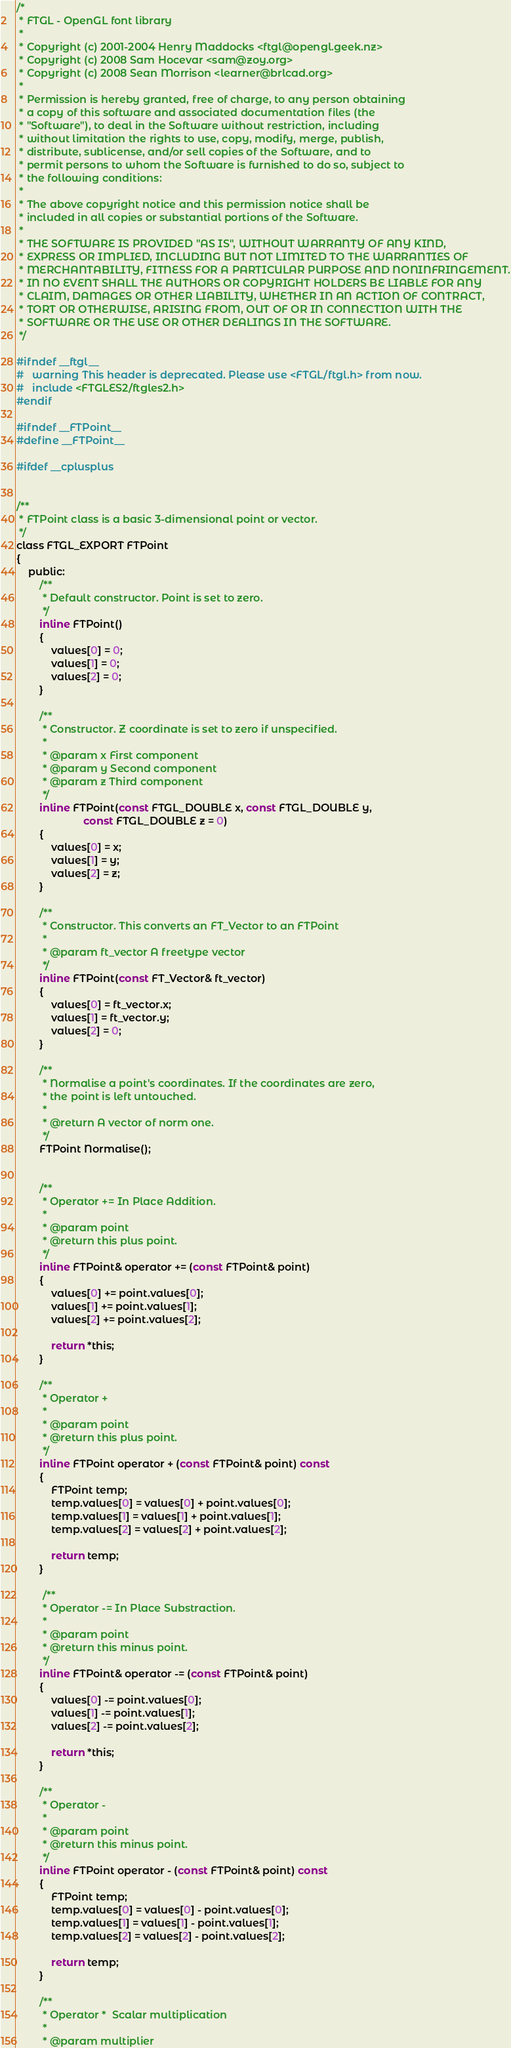Convert code to text. <code><loc_0><loc_0><loc_500><loc_500><_C_>/*
 * FTGL - OpenGL font library
 *
 * Copyright (c) 2001-2004 Henry Maddocks <ftgl@opengl.geek.nz>
 * Copyright (c) 2008 Sam Hocevar <sam@zoy.org>
 * Copyright (c) 2008 Sean Morrison <learner@brlcad.org>
 *
 * Permission is hereby granted, free of charge, to any person obtaining
 * a copy of this software and associated documentation files (the
 * "Software"), to deal in the Software without restriction, including
 * without limitation the rights to use, copy, modify, merge, publish,
 * distribute, sublicense, and/or sell copies of the Software, and to
 * permit persons to whom the Software is furnished to do so, subject to
 * the following conditions:
 *
 * The above copyright notice and this permission notice shall be
 * included in all copies or substantial portions of the Software.
 *
 * THE SOFTWARE IS PROVIDED "AS IS", WITHOUT WARRANTY OF ANY KIND,
 * EXPRESS OR IMPLIED, INCLUDING BUT NOT LIMITED TO THE WARRANTIES OF
 * MERCHANTABILITY, FITNESS FOR A PARTICULAR PURPOSE AND NONINFRINGEMENT.
 * IN NO EVENT SHALL THE AUTHORS OR COPYRIGHT HOLDERS BE LIABLE FOR ANY
 * CLAIM, DAMAGES OR OTHER LIABILITY, WHETHER IN AN ACTION OF CONTRACT,
 * TORT OR OTHERWISE, ARISING FROM, OUT OF OR IN CONNECTION WITH THE
 * SOFTWARE OR THE USE OR OTHER DEALINGS IN THE SOFTWARE.
 */

#ifndef __ftgl__
#   warning This header is deprecated. Please use <FTGL/ftgl.h> from now.
#   include <FTGLES2/ftgles2.h>
#endif

#ifndef __FTPoint__
#define __FTPoint__

#ifdef __cplusplus


/**
 * FTPoint class is a basic 3-dimensional point or vector.
 */
class FTGL_EXPORT FTPoint
{
    public:
        /**
         * Default constructor. Point is set to zero.
         */
        inline FTPoint()
        {
            values[0] = 0;
            values[1] = 0;
            values[2] = 0;
        }

        /**
         * Constructor. Z coordinate is set to zero if unspecified.
         *
         * @param x First component
         * @param y Second component
         * @param z Third component
         */
        inline FTPoint(const FTGL_DOUBLE x, const FTGL_DOUBLE y,
                       const FTGL_DOUBLE z = 0)
        {
            values[0] = x;
            values[1] = y;
            values[2] = z;
        }

        /**
         * Constructor. This converts an FT_Vector to an FTPoint
         *
         * @param ft_vector A freetype vector
         */
        inline FTPoint(const FT_Vector& ft_vector)
        {
            values[0] = ft_vector.x;
            values[1] = ft_vector.y;
            values[2] = 0;
        }

        /**
         * Normalise a point's coordinates. If the coordinates are zero,
         * the point is left untouched.
         *
         * @return A vector of norm one.
         */
        FTPoint Normalise();


        /**
         * Operator += In Place Addition.
         *
         * @param point
         * @return this plus point.
         */
        inline FTPoint& operator += (const FTPoint& point)
        {
            values[0] += point.values[0];
            values[1] += point.values[1];
            values[2] += point.values[2];

            return *this;
        }

        /**
         * Operator +
         *
         * @param point
         * @return this plus point.
         */
        inline FTPoint operator + (const FTPoint& point) const
        {
            FTPoint temp;
            temp.values[0] = values[0] + point.values[0];
            temp.values[1] = values[1] + point.values[1];
            temp.values[2] = values[2] + point.values[2];

            return temp;
        }

         /**
         * Operator -= In Place Substraction.
         *
         * @param point
         * @return this minus point.
         */
        inline FTPoint& operator -= (const FTPoint& point)
        {
            values[0] -= point.values[0];
            values[1] -= point.values[1];
            values[2] -= point.values[2];

            return *this;
        }

        /**
         * Operator -
         *
         * @param point
         * @return this minus point.
         */
        inline FTPoint operator - (const FTPoint& point) const
        {
            FTPoint temp;
            temp.values[0] = values[0] - point.values[0];
            temp.values[1] = values[1] - point.values[1];
            temp.values[2] = values[2] - point.values[2];

            return temp;
        }

        /**
         * Operator *  Scalar multiplication
         *
         * @param multiplier</code> 